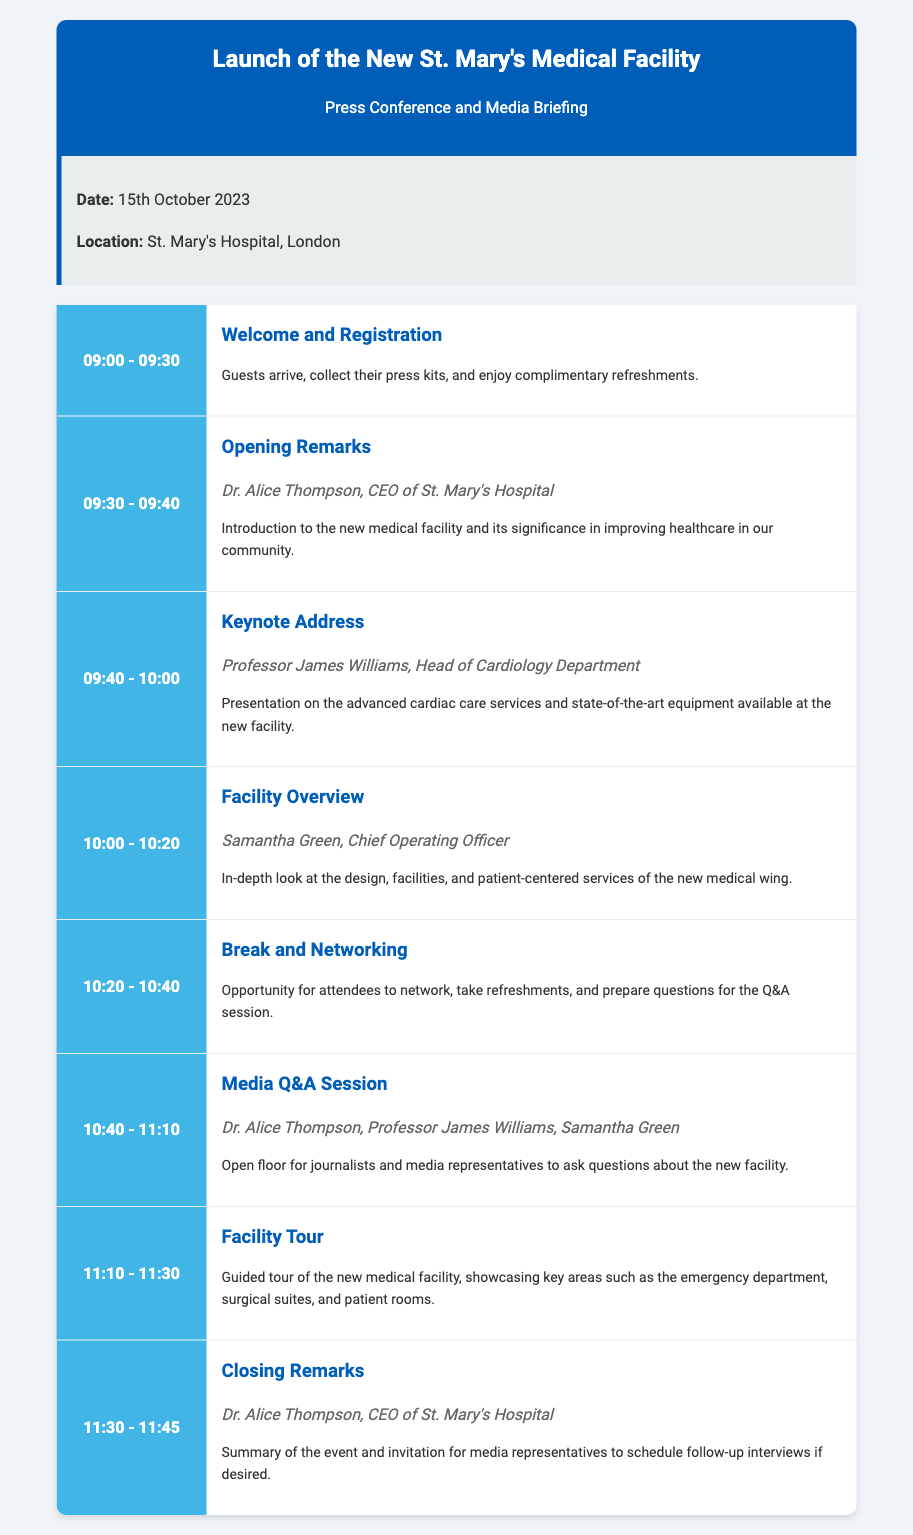What is the date of the event? The date of the event is explicitly stated in the document.
Answer: 15th October 2023 Who is the keynote speaker? The document lists the keynote speaker in the schedule.
Answer: Professor James Williams What time does the facility tour start? The schedule provides specific timings for each event, including the facility tour.
Answer: 11:10 How long is the Media Q&A Session? The duration of the Media Q&A Session can be calculated from the schedule timings provided.
Answer: 30 minutes What is the activity before the closing remarks? The activity immediately preceding the closing remarks is mentioned in the schedule.
Answer: Facility Tour Who gives the opening remarks? The document states the person responsible for the opening remarks.
Answer: Dr. Alice Thompson What type of event is this? The nature of the event is specified in the title section of the document.
Answer: Press Conference and Media Briefing What is the location of the launch? The document clearly indicates the location of the event.
Answer: St. Mary's Hospital, London 